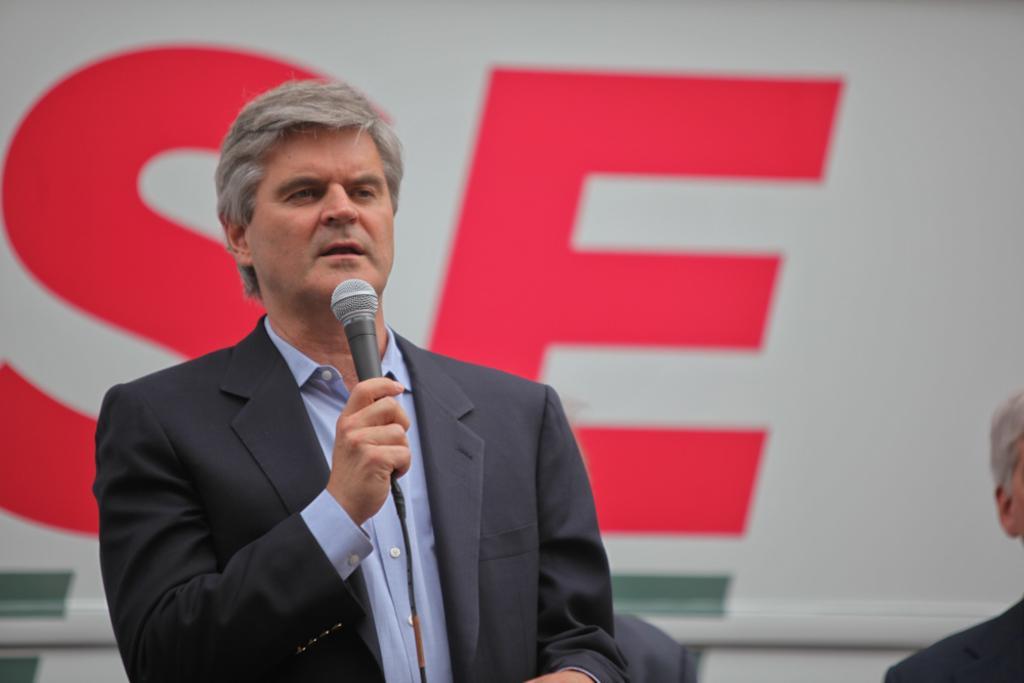In one or two sentences, can you explain what this image depicts? In this image I see a man who is holding the mic and I can also see there is another man over here, I also see that this man is wearing a suit. 